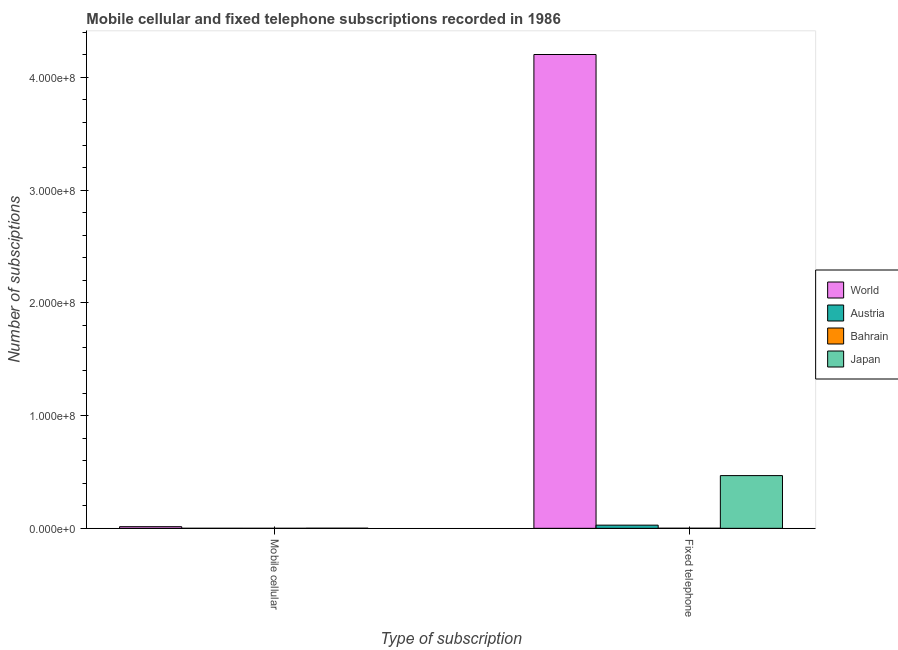How many different coloured bars are there?
Make the answer very short. 4. Are the number of bars per tick equal to the number of legend labels?
Ensure brevity in your answer.  Yes. What is the label of the 1st group of bars from the left?
Your answer should be compact. Mobile cellular. What is the number of mobile cellular subscriptions in Japan?
Provide a succinct answer. 9.51e+04. Across all countries, what is the maximum number of fixed telephone subscriptions?
Keep it short and to the point. 4.20e+08. Across all countries, what is the minimum number of mobile cellular subscriptions?
Give a very brief answer. 618. In which country was the number of fixed telephone subscriptions maximum?
Your answer should be compact. World. In which country was the number of mobile cellular subscriptions minimum?
Make the answer very short. Bahrain. What is the total number of fixed telephone subscriptions in the graph?
Make the answer very short. 4.70e+08. What is the difference between the number of mobile cellular subscriptions in Austria and that in World?
Offer a terse response. -1.43e+06. What is the difference between the number of mobile cellular subscriptions in World and the number of fixed telephone subscriptions in Austria?
Give a very brief answer. -1.37e+06. What is the average number of fixed telephone subscriptions per country?
Keep it short and to the point. 1.18e+08. What is the difference between the number of fixed telephone subscriptions and number of mobile cellular subscriptions in Japan?
Your answer should be very brief. 4.67e+07. What is the ratio of the number of mobile cellular subscriptions in Japan to that in Austria?
Ensure brevity in your answer.  4.98. In how many countries, is the number of fixed telephone subscriptions greater than the average number of fixed telephone subscriptions taken over all countries?
Provide a short and direct response. 1. What does the 3rd bar from the left in Mobile cellular represents?
Offer a very short reply. Bahrain. How many bars are there?
Your answer should be compact. 8. Does the graph contain grids?
Provide a succinct answer. No. What is the title of the graph?
Provide a short and direct response. Mobile cellular and fixed telephone subscriptions recorded in 1986. What is the label or title of the X-axis?
Your response must be concise. Type of subscription. What is the label or title of the Y-axis?
Provide a succinct answer. Number of subsciptions. What is the Number of subsciptions in World in Mobile cellular?
Your response must be concise. 1.45e+06. What is the Number of subsciptions in Austria in Mobile cellular?
Your response must be concise. 1.91e+04. What is the Number of subsciptions in Bahrain in Mobile cellular?
Make the answer very short. 618. What is the Number of subsciptions in Japan in Mobile cellular?
Offer a very short reply. 9.51e+04. What is the Number of subsciptions in World in Fixed telephone?
Your answer should be compact. 4.20e+08. What is the Number of subsciptions of Austria in Fixed telephone?
Your answer should be compact. 2.82e+06. What is the Number of subsciptions in Bahrain in Fixed telephone?
Your answer should be very brief. 7.29e+04. What is the Number of subsciptions in Japan in Fixed telephone?
Provide a succinct answer. 4.68e+07. Across all Type of subscription, what is the maximum Number of subsciptions in World?
Give a very brief answer. 4.20e+08. Across all Type of subscription, what is the maximum Number of subsciptions of Austria?
Provide a short and direct response. 2.82e+06. Across all Type of subscription, what is the maximum Number of subsciptions of Bahrain?
Make the answer very short. 7.29e+04. Across all Type of subscription, what is the maximum Number of subsciptions in Japan?
Offer a terse response. 4.68e+07. Across all Type of subscription, what is the minimum Number of subsciptions of World?
Provide a short and direct response. 1.45e+06. Across all Type of subscription, what is the minimum Number of subsciptions of Austria?
Keep it short and to the point. 1.91e+04. Across all Type of subscription, what is the minimum Number of subsciptions of Bahrain?
Provide a short and direct response. 618. Across all Type of subscription, what is the minimum Number of subsciptions of Japan?
Your response must be concise. 9.51e+04. What is the total Number of subsciptions of World in the graph?
Ensure brevity in your answer.  4.22e+08. What is the total Number of subsciptions of Austria in the graph?
Keep it short and to the point. 2.84e+06. What is the total Number of subsciptions of Bahrain in the graph?
Provide a short and direct response. 7.35e+04. What is the total Number of subsciptions of Japan in the graph?
Your answer should be compact. 4.69e+07. What is the difference between the Number of subsciptions of World in Mobile cellular and that in Fixed telephone?
Make the answer very short. -4.19e+08. What is the difference between the Number of subsciptions in Austria in Mobile cellular and that in Fixed telephone?
Offer a terse response. -2.80e+06. What is the difference between the Number of subsciptions in Bahrain in Mobile cellular and that in Fixed telephone?
Keep it short and to the point. -7.23e+04. What is the difference between the Number of subsciptions of Japan in Mobile cellular and that in Fixed telephone?
Your response must be concise. -4.67e+07. What is the difference between the Number of subsciptions in World in Mobile cellular and the Number of subsciptions in Austria in Fixed telephone?
Keep it short and to the point. -1.37e+06. What is the difference between the Number of subsciptions in World in Mobile cellular and the Number of subsciptions in Bahrain in Fixed telephone?
Keep it short and to the point. 1.38e+06. What is the difference between the Number of subsciptions in World in Mobile cellular and the Number of subsciptions in Japan in Fixed telephone?
Your response must be concise. -4.53e+07. What is the difference between the Number of subsciptions in Austria in Mobile cellular and the Number of subsciptions in Bahrain in Fixed telephone?
Your answer should be compact. -5.38e+04. What is the difference between the Number of subsciptions in Austria in Mobile cellular and the Number of subsciptions in Japan in Fixed telephone?
Offer a terse response. -4.68e+07. What is the difference between the Number of subsciptions in Bahrain in Mobile cellular and the Number of subsciptions in Japan in Fixed telephone?
Make the answer very short. -4.68e+07. What is the average Number of subsciptions of World per Type of subscription?
Give a very brief answer. 2.11e+08. What is the average Number of subsciptions of Austria per Type of subscription?
Give a very brief answer. 1.42e+06. What is the average Number of subsciptions of Bahrain per Type of subscription?
Your response must be concise. 3.68e+04. What is the average Number of subsciptions of Japan per Type of subscription?
Your answer should be very brief. 2.34e+07. What is the difference between the Number of subsciptions in World and Number of subsciptions in Austria in Mobile cellular?
Offer a terse response. 1.43e+06. What is the difference between the Number of subsciptions of World and Number of subsciptions of Bahrain in Mobile cellular?
Give a very brief answer. 1.45e+06. What is the difference between the Number of subsciptions in World and Number of subsciptions in Japan in Mobile cellular?
Keep it short and to the point. 1.36e+06. What is the difference between the Number of subsciptions of Austria and Number of subsciptions of Bahrain in Mobile cellular?
Make the answer very short. 1.85e+04. What is the difference between the Number of subsciptions of Austria and Number of subsciptions of Japan in Mobile cellular?
Your answer should be very brief. -7.60e+04. What is the difference between the Number of subsciptions in Bahrain and Number of subsciptions in Japan in Mobile cellular?
Offer a terse response. -9.45e+04. What is the difference between the Number of subsciptions of World and Number of subsciptions of Austria in Fixed telephone?
Your answer should be compact. 4.18e+08. What is the difference between the Number of subsciptions in World and Number of subsciptions in Bahrain in Fixed telephone?
Provide a short and direct response. 4.20e+08. What is the difference between the Number of subsciptions in World and Number of subsciptions in Japan in Fixed telephone?
Ensure brevity in your answer.  3.74e+08. What is the difference between the Number of subsciptions of Austria and Number of subsciptions of Bahrain in Fixed telephone?
Provide a succinct answer. 2.75e+06. What is the difference between the Number of subsciptions in Austria and Number of subsciptions in Japan in Fixed telephone?
Provide a short and direct response. -4.40e+07. What is the difference between the Number of subsciptions of Bahrain and Number of subsciptions of Japan in Fixed telephone?
Ensure brevity in your answer.  -4.67e+07. What is the ratio of the Number of subsciptions in World in Mobile cellular to that in Fixed telephone?
Make the answer very short. 0. What is the ratio of the Number of subsciptions in Austria in Mobile cellular to that in Fixed telephone?
Offer a very short reply. 0.01. What is the ratio of the Number of subsciptions of Bahrain in Mobile cellular to that in Fixed telephone?
Your answer should be compact. 0.01. What is the ratio of the Number of subsciptions of Japan in Mobile cellular to that in Fixed telephone?
Your answer should be very brief. 0. What is the difference between the highest and the second highest Number of subsciptions of World?
Your answer should be very brief. 4.19e+08. What is the difference between the highest and the second highest Number of subsciptions in Austria?
Ensure brevity in your answer.  2.80e+06. What is the difference between the highest and the second highest Number of subsciptions in Bahrain?
Offer a terse response. 7.23e+04. What is the difference between the highest and the second highest Number of subsciptions of Japan?
Ensure brevity in your answer.  4.67e+07. What is the difference between the highest and the lowest Number of subsciptions in World?
Offer a terse response. 4.19e+08. What is the difference between the highest and the lowest Number of subsciptions of Austria?
Make the answer very short. 2.80e+06. What is the difference between the highest and the lowest Number of subsciptions of Bahrain?
Your response must be concise. 7.23e+04. What is the difference between the highest and the lowest Number of subsciptions of Japan?
Provide a succinct answer. 4.67e+07. 